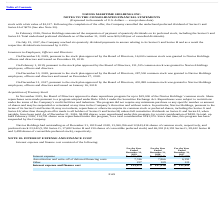From Navios Maritime Holdings's financial document, Which years does the table provide information for the company's Interest expense and finance cost? The document contains multiple relevant values: 2019, 2018, 2017. From the document: "On July 15, 2017, the Company reached six quarterly dividend payments in arrears relating to its Series G and Series undeclared preferred dividends as..." Also, What was the Amortization and write-off of deferred financing costs in 2019? According to the financial document, 7,746 (in thousands). The relevant text states: "ization and write-off of deferred financing costs 7,746 7,866 6,391..." Also, What was the Interest expense and finance cost in 2017? According to the financial document, 121,611 (in thousands). The relevant text states: "st expense and finance cost $ 133,479 $ 137,916 $ 121,611..." Also, How many years did Other expense and cost exceed $100 thousand? Counting the relevant items in the document: 2019, 2018, 2017, I find 3 instances. The key data points involved are: 2017, 2018, 2019. Also, can you calculate: What was the change in Interest expense between 2017 and 2018? Based on the calculation: 129,941-115,099, the result is 14842 (in thousands). This is based on the information: "Interest expense $ 125,496 $ 129,941 $ 115,099 Interest expense $ 125,496 $ 129,941 $ 115,099..." The key data points involved are: 115,099, 129,941. Also, can you calculate: What was the percentage change in the Interest expense and finance cost between 2018 and 2019? To answer this question, I need to perform calculations using the financial data. The calculation is: (133,479-137,916)/137,916, which equals -3.22 (percentage). This is based on the information: "Interest expense and finance cost $ 133,479 $ 137,916 $ 121,611 Interest expense and finance cost $ 133,479 $ 137,916 $ 121,611..." The key data points involved are: 133,479, 137,916. 